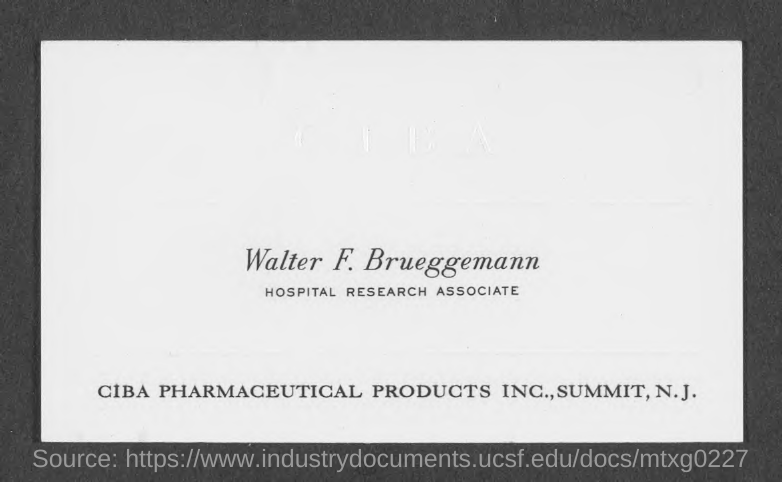Point out several critical features in this image. Walter F. Brueggemann is a Hospital Research Associate. 